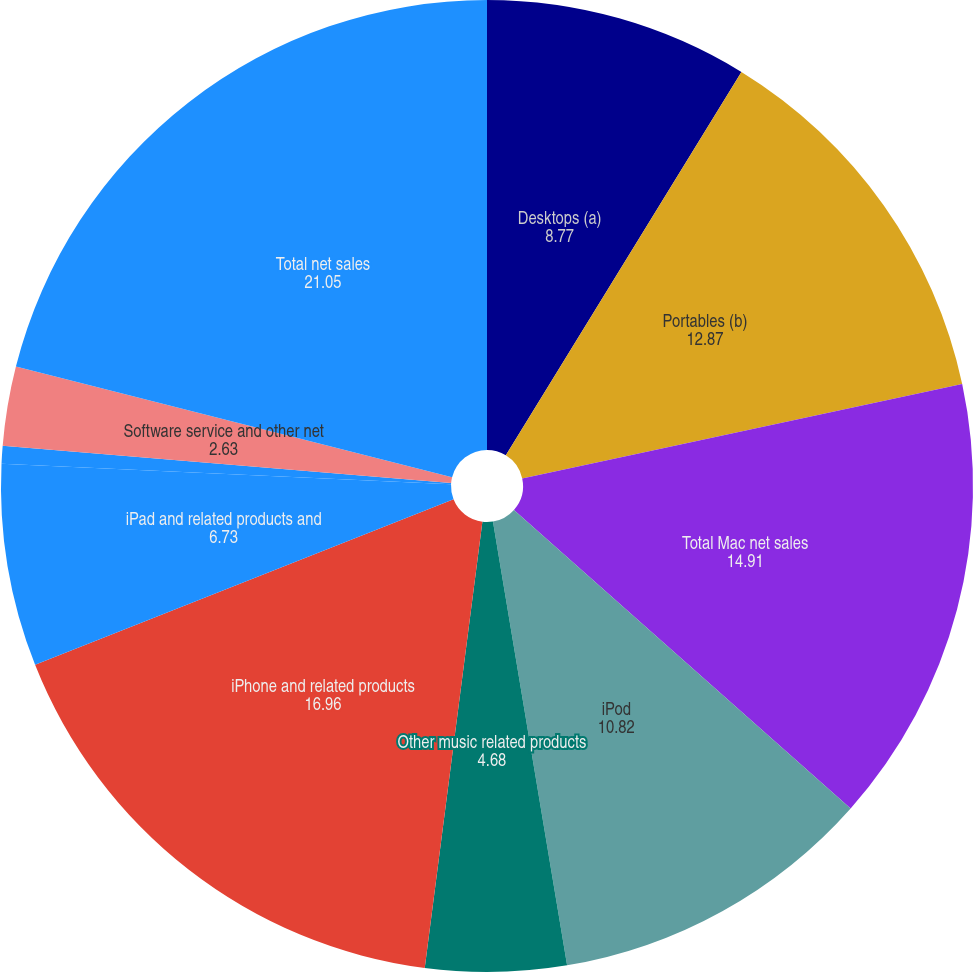<chart> <loc_0><loc_0><loc_500><loc_500><pie_chart><fcel>Desktops (a)<fcel>Portables (b)<fcel>Total Mac net sales<fcel>iPod<fcel>Other music related products<fcel>iPhone and related products<fcel>iPad and related products and<fcel>Peripherals and other hardware<fcel>Software service and other net<fcel>Total net sales<nl><fcel>8.77%<fcel>12.87%<fcel>14.91%<fcel>10.82%<fcel>4.68%<fcel>16.96%<fcel>6.73%<fcel>0.59%<fcel>2.63%<fcel>21.05%<nl></chart> 